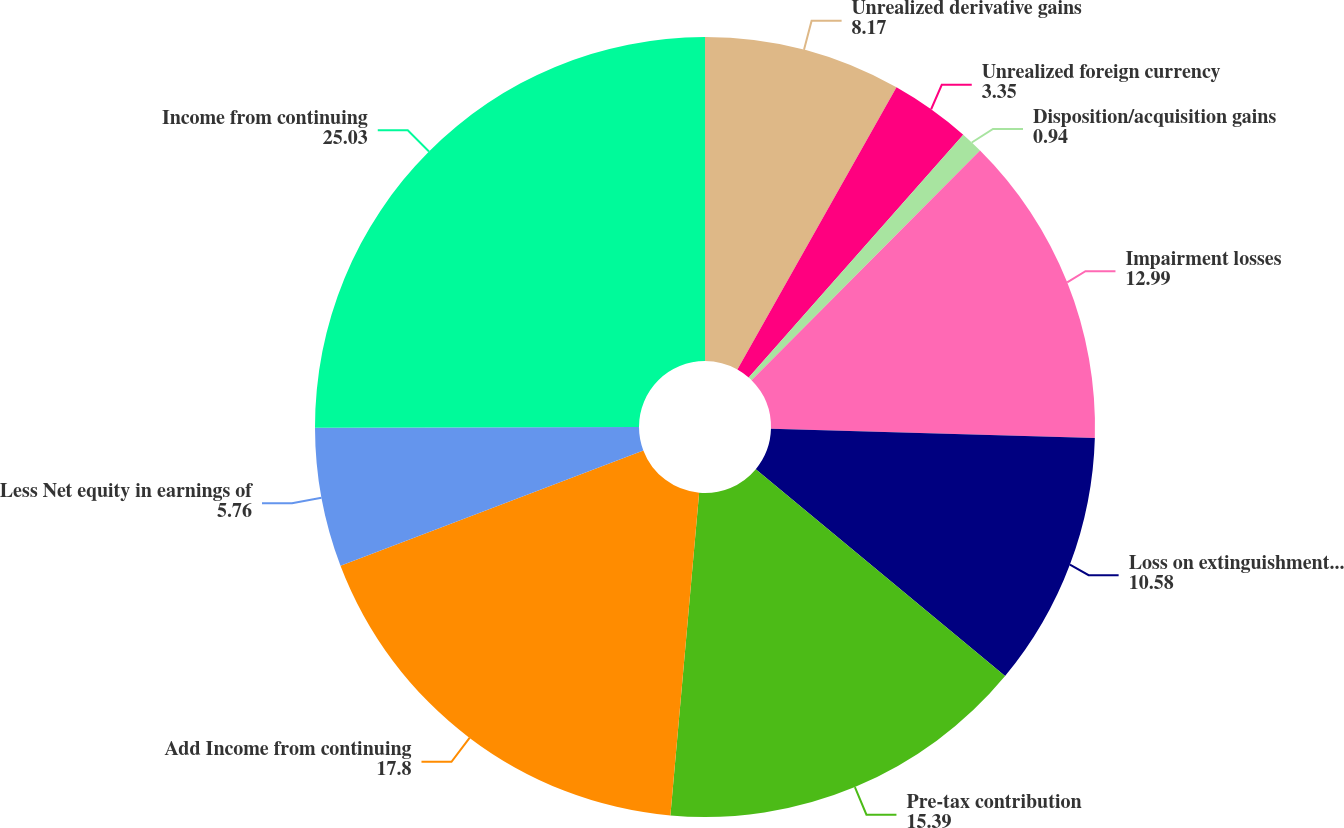<chart> <loc_0><loc_0><loc_500><loc_500><pie_chart><fcel>Unrealized derivative gains<fcel>Unrealized foreign currency<fcel>Disposition/acquisition gains<fcel>Impairment losses<fcel>Loss on extinguishment of debt<fcel>Pre-tax contribution<fcel>Add Income from continuing<fcel>Less Net equity in earnings of<fcel>Income from continuing<nl><fcel>8.17%<fcel>3.35%<fcel>0.94%<fcel>12.99%<fcel>10.58%<fcel>15.39%<fcel>17.8%<fcel>5.76%<fcel>25.03%<nl></chart> 